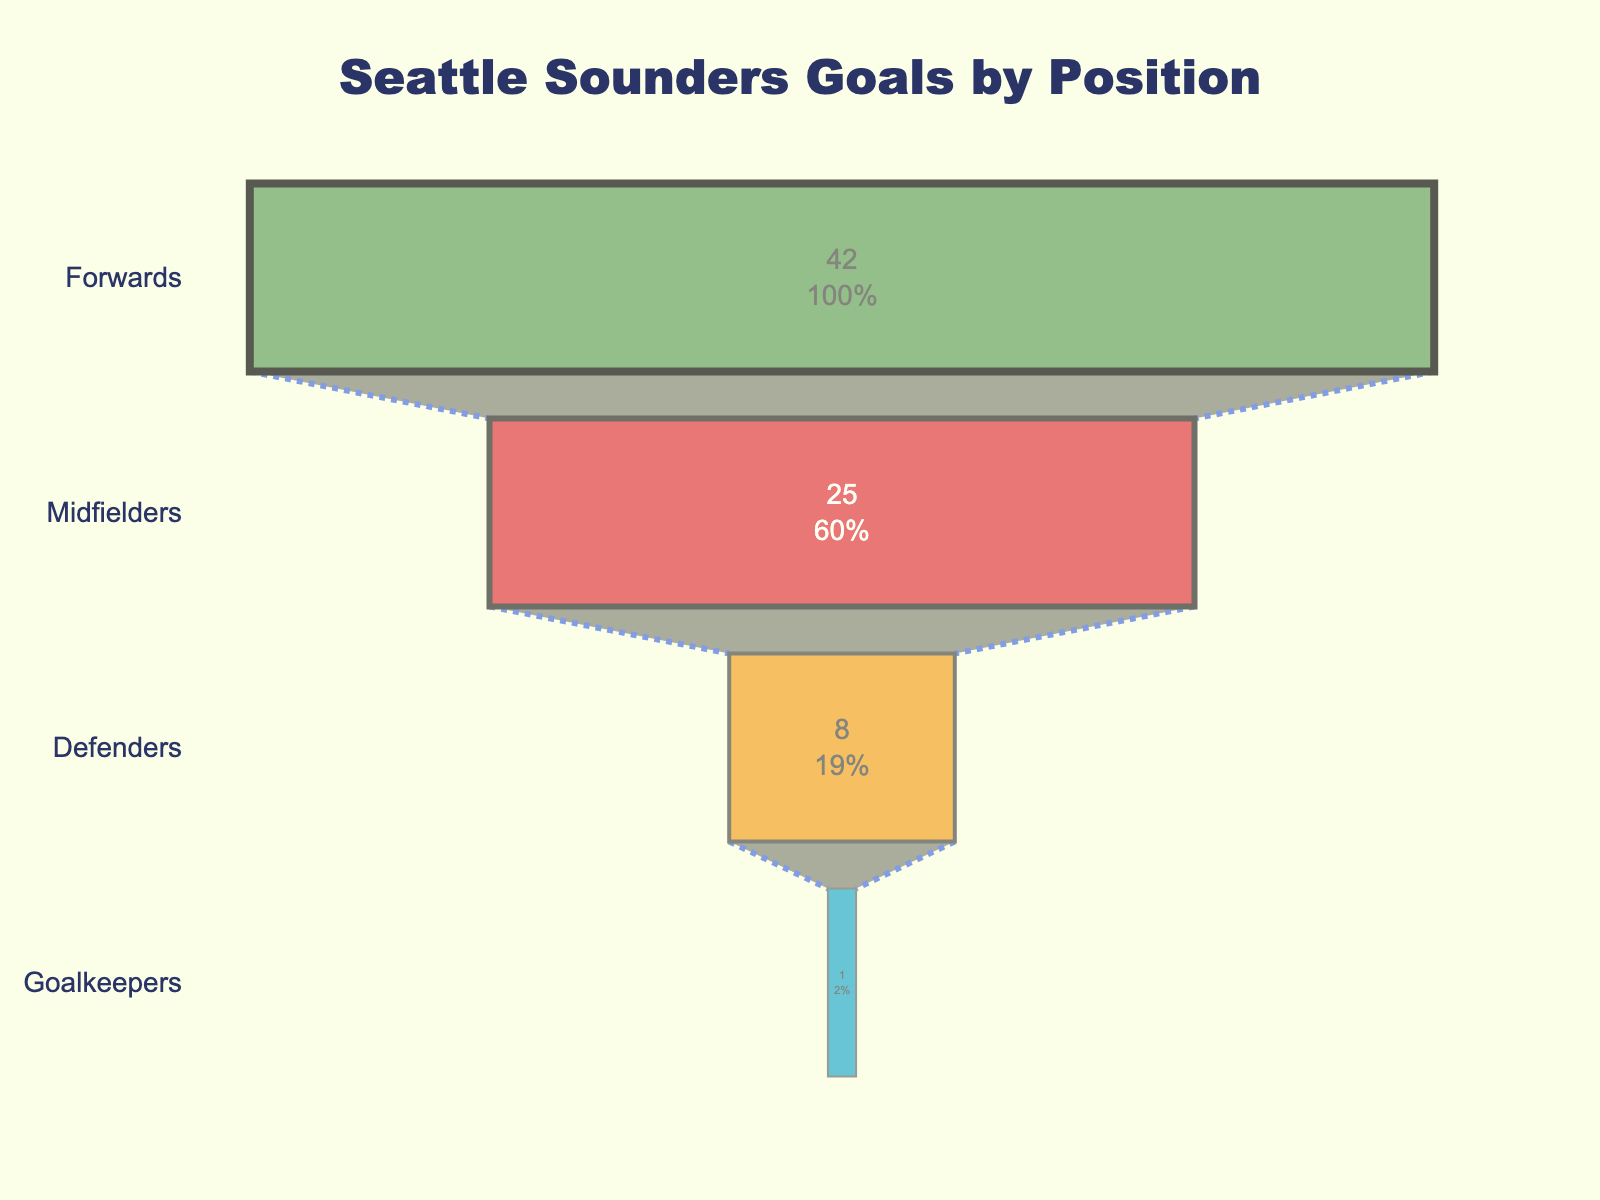How many goals were scored by the midfielders? The funnel chart shows the number of goals scored by each position. Locate the 'Midfielders' field and read the corresponding value.
Answer: 25 What's the total number of goals scored by all positions combined? Add the number of goals for all positions together: Forwards (42) + Midfielders (25) + Defenders (8) + Goalkeepers (1).
Answer: 76 What's the percentage of goals scored by defenders relative to the total goals? First, find the total number of goals scored: 76. Then, calculate the percentage for defenders: (8/76) * 100.
Answer: 10.53% Which position scored the least number of goals? Compare the numbers for each position. The position with the smallest number is the one we are looking for.
Answer: Goalkeepers How many more goals did the forwards score compared to the midfielders? Subtract the number of goals scored by the midfielders from those scored by the forwards: 42 - 25.
Answer: 17 If the goalkeepers scored one more goal, what would be the new total number of goals for all positions? Add 1 to the current goalkeeper goals, then sum all positions again: 1 + 1 + 42 + 25 + 8.
Answer: 77 Which two positions together scored more than 50% of the total goals? Calculate the combined goals for different pairs and check if they exceed 50% of 76, i.e., 38. Forwards and Midfielders together: 42 + 25.
Answer: Forwards and Midfielders What's the difference in percentage of goals scored by forwards and defenders? Calculate percentages for both: Forwards (42/76 * 100) and Defenders (8/76 * 100). Take the difference.
Answer: 44.74% Which positions are responsible for more than 30% of the goals each? Calculate 30% of total goals: 30/100 * 76 = 22.8. Compare with goals by each position.
Answer: Forwards and Midfielders How many times more goals did forwards score compared to goalkeepers? Divide the goals scored by forwards by the goals from goalkeepers: 42/1.
Answer: 42 